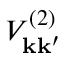Convert formula to latex. <formula><loc_0><loc_0><loc_500><loc_500>V _ { k k ^ { \prime } } ^ { ( 2 ) }</formula> 